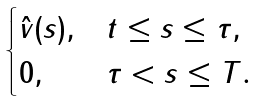Convert formula to latex. <formula><loc_0><loc_0><loc_500><loc_500>\begin{cases} \hat { v } ( s ) , & t \leq s \leq \tau , \\ 0 , & \tau < s \leq T . \end{cases}</formula> 